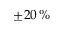Convert formula to latex. <formula><loc_0><loc_0><loc_500><loc_500>\pm 2 0 \, \%</formula> 